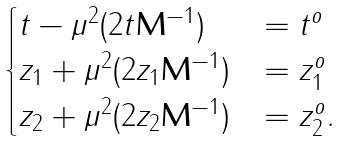Convert formula to latex. <formula><loc_0><loc_0><loc_500><loc_500>\begin{cases} t - \mu ^ { 2 } ( 2 t \mathbf M ^ { - 1 } ) & = t ^ { o } \\ z _ { 1 } + \mu ^ { 2 } ( 2 z _ { 1 } \mathbf M ^ { - 1 } ) & = z _ { 1 } ^ { o } \\ z _ { 2 } + \mu ^ { 2 } ( 2 z _ { 2 } \mathbf M ^ { - 1 } ) & = z _ { 2 } ^ { o } . \end{cases}</formula> 